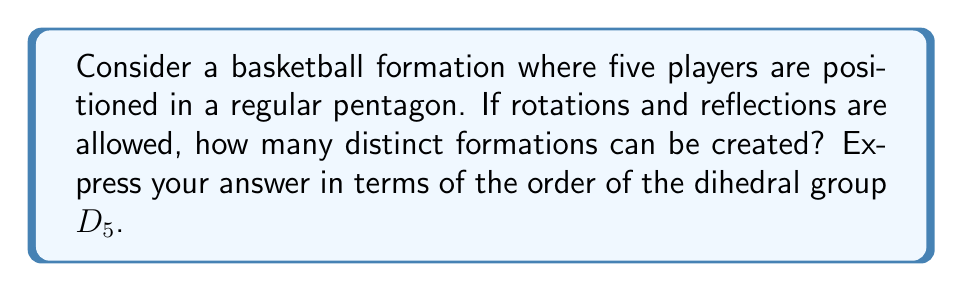Can you solve this math problem? Let's approach this step-by-step:

1) The dihedral group $D_5$ represents the symmetries of a regular pentagon. It includes rotations and reflections.

2) The order of $D_5$ is given by the formula:
   $$|D_5| = 2n = 2(5) = 10$$
   where $n$ is the number of sides in the polygon (5 in this case).

3) Each symmetry operation in $D_5$ corresponds to a distinct formation of the players.

4) However, we need to consider that the players are distinguishable (e.g., they have different positions or roles).

5) For each symmetry operation, we have 5! ways to arrange the 5 players in the resulting formation.

6) Therefore, the total number of distinct formations is:
   $$|D_5| \times 5!$$

7) Substituting the value of $|D_5|$:
   $$10 \times 5! = 10 \times 120 = 1200$$

Thus, there are 1200 distinct formations possible.
Answer: $|D_5| \times 5!$ 